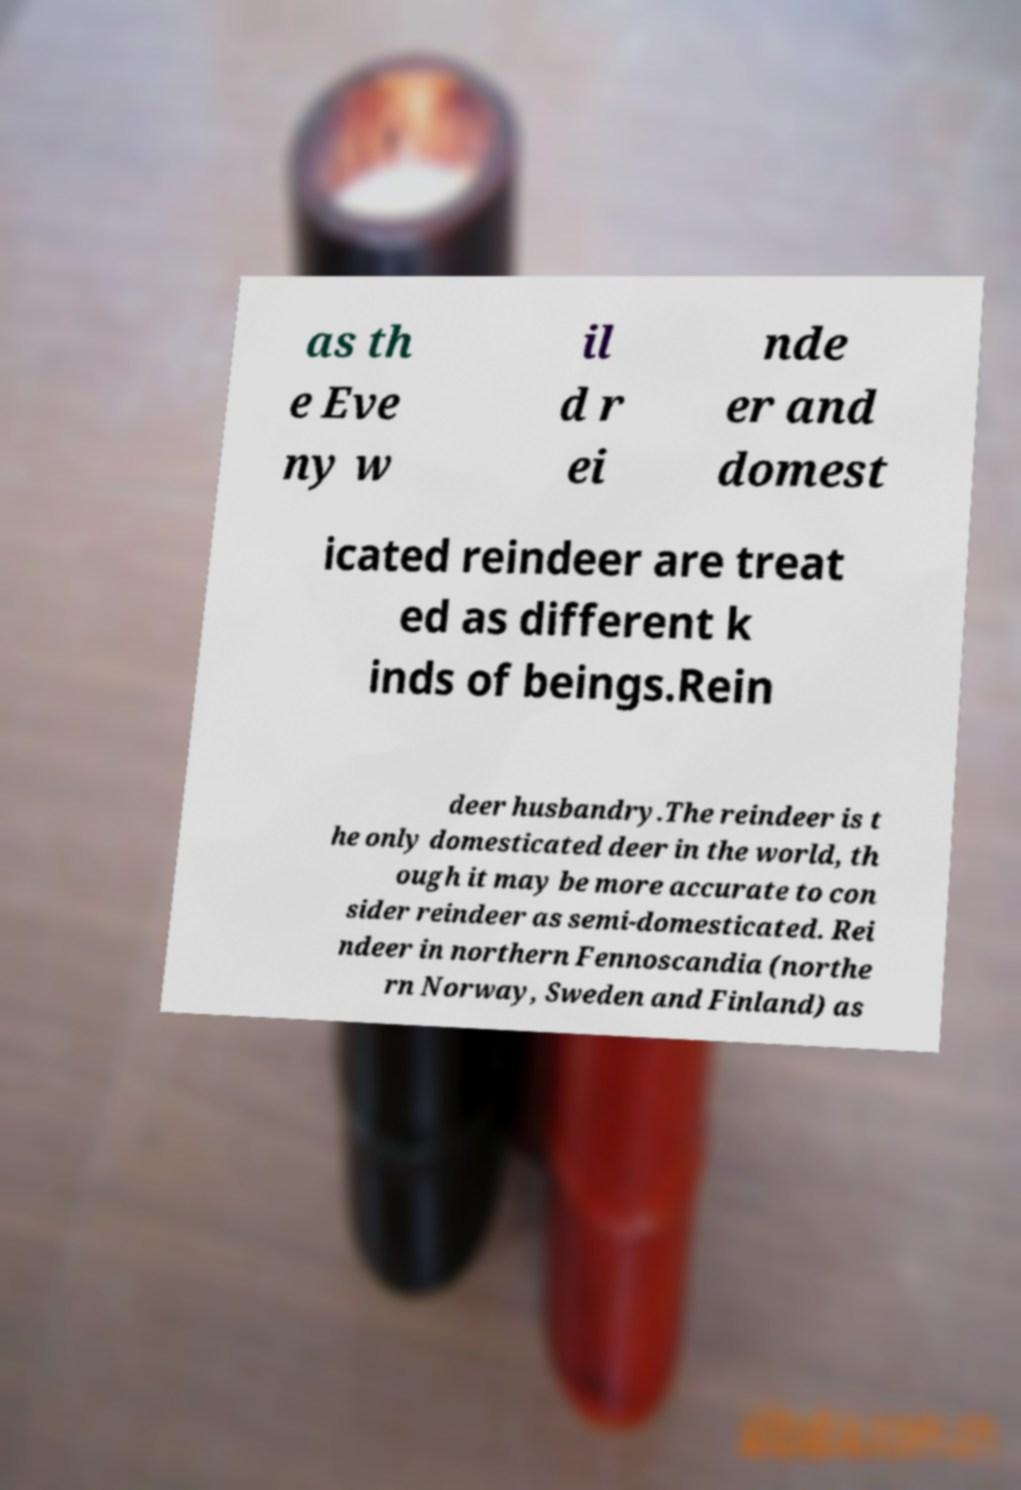Please read and relay the text visible in this image. What does it say? as th e Eve ny w il d r ei nde er and domest icated reindeer are treat ed as different k inds of beings.Rein deer husbandry.The reindeer is t he only domesticated deer in the world, th ough it may be more accurate to con sider reindeer as semi-domesticated. Rei ndeer in northern Fennoscandia (northe rn Norway, Sweden and Finland) as 